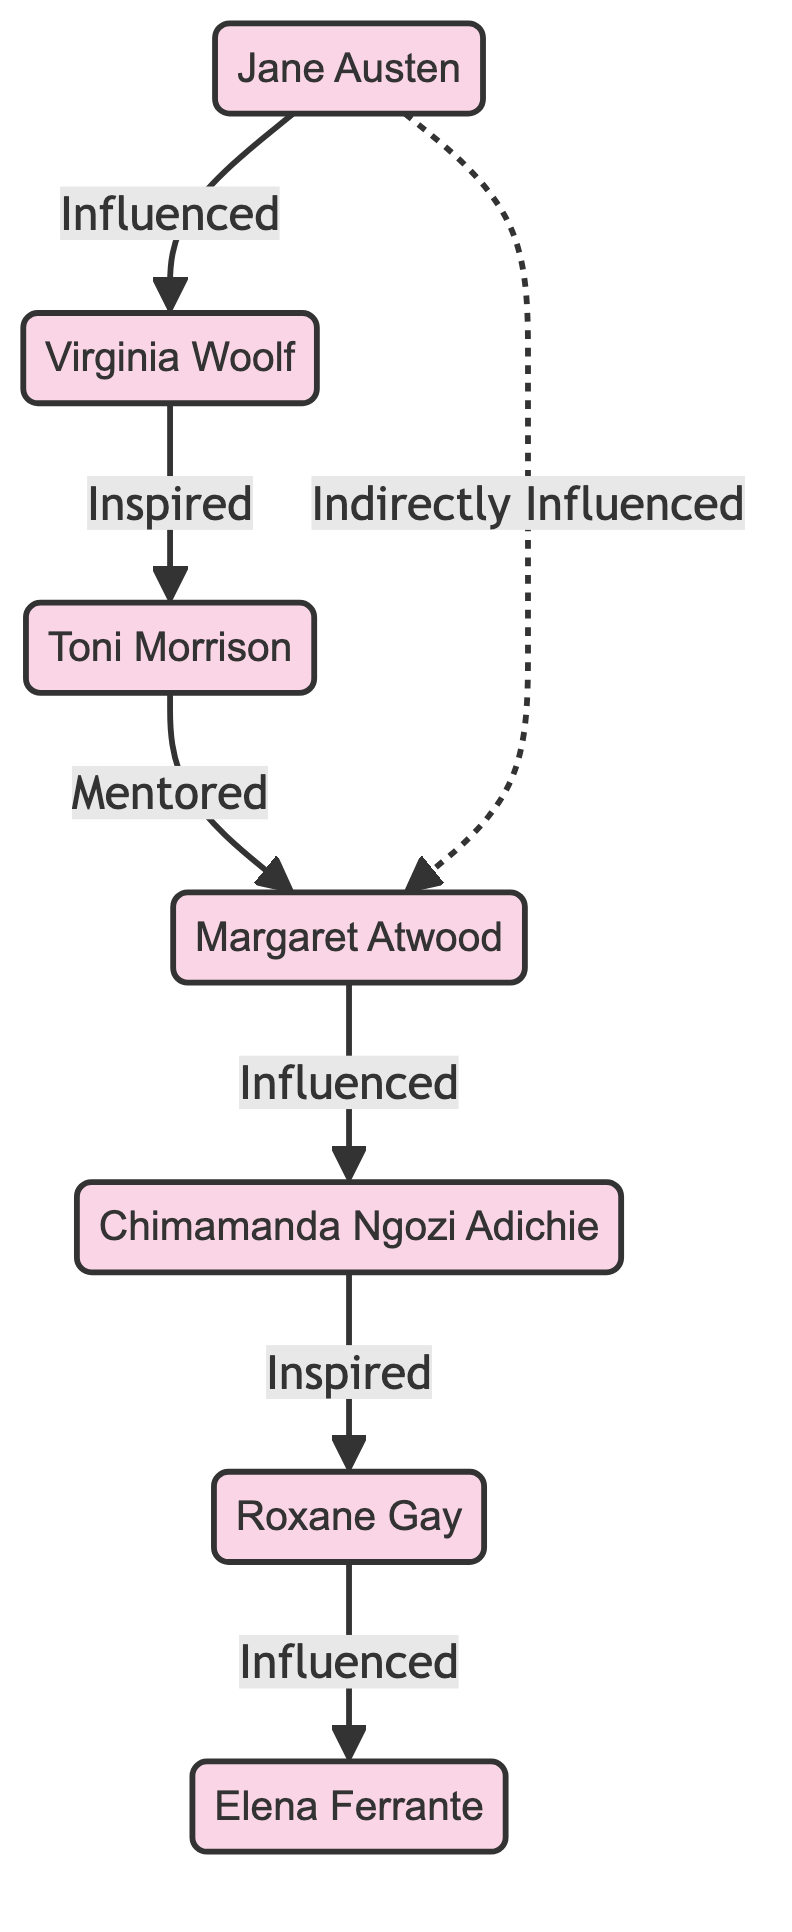What is the total number of nodes in the graph? The graph lists seven distinct authors as individual nodes: Jane Austen, Virginia Woolf, Toni Morrison, Margaret Atwood, Chimamanda Ngozi Adichie, Roxane Gay, and Elena Ferrante. Counting these, the total number of nodes is 7.
Answer: 7 Who directly influenced Virginia Woolf? According to the diagram, the edge pointing from Jane Austen to Virginia Woolf signifies that Jane Austen directly influenced her. Hence, the answer is Jane Austen.
Answer: Jane Austen Which author is mentored by Toni Morrison? The diagram shows a directed edge from Toni Morrison to Margaret Atwood, indicating that Toni Morrison mentors Margaret Atwood. Therefore, the answer is Margaret Atwood.
Answer: Margaret Atwood How many authors did Jane Austen influence directly or indirectly? Jane Austen influences Virginia Woolf directly and also has an indirect influence on Margaret Atwood through Virginia Woolf and Toni Morrison. Therefore, counting both direct and indirect, the total is 2.
Answer: 2 Who is the last author influenced by Roxane Gay? The diagram shows a directed edge from Roxane Gay to Elena Ferrante, indicating that Roxane Gay is the author who influences Elena Ferrante. Thus, the answer is Elena Ferrante.
Answer: Elena Ferrante What kind of relationship exists between Jane Austen and Margaret Atwood? The diagram features two types of relationships: Jane Austen directly influences Virginia Woolf, who influences Toni Morrison, and Toni Morrison mentors Margaret Atwood. Additionally, Jane Austen has an indirect influence on Margaret Atwood represented by a dashed line. Therefore, the relationship is both direct (through Virginia Woolf and Toni Morrison) and indirect.
Answer: Direct and Indirect Which two authors are connected by the strongest mentorship bond? The strongest mentorship bond in the diagram is represented by the edge from Toni Morrison to Margaret Atwood, indicating a mentorship relationship, which is more direct than influences. Hence, the answer is Toni Morrison and Margaret Atwood.
Answer: Toni Morrison and Margaret Atwood 